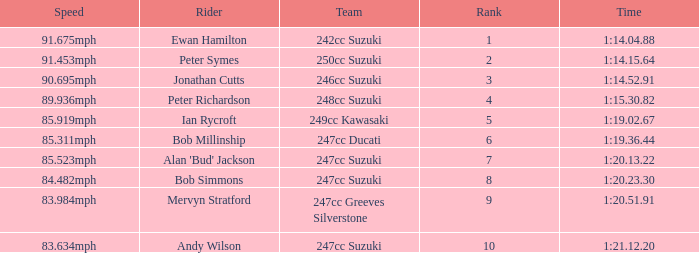Which team had a rank under 4 with a time of 1:14.04.88? 242cc Suzuki. 